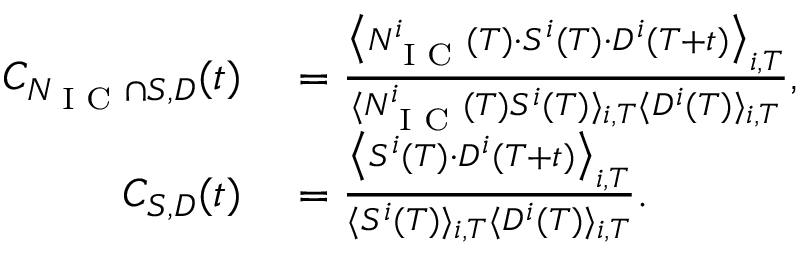Convert formula to latex. <formula><loc_0><loc_0><loc_500><loc_500>\begin{array} { r l } { C _ { N _ { I C } \cap S , D } ( t ) } & = \frac { \left \langle N _ { I C } ^ { i } ( T ) \cdot S ^ { i } ( T ) \cdot D ^ { i } ( T + t ) \right \rangle _ { i , T } } { { \langle N _ { I C } ^ { i } ( T ) S ^ { i } ( T ) \rangle _ { i , T } \langle D ^ { i } ( T ) \rangle _ { i , T } } } , } \\ { C _ { S , D } ( t ) } & = \frac { \left \langle S ^ { i } ( T ) \cdot D ^ { i } ( T + t ) \right \rangle _ { i , T } } { \langle S ^ { i } ( T ) \rangle _ { i , T } \langle D ^ { i } ( T ) \rangle _ { i , T } } . } \end{array}</formula> 